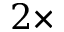Convert formula to latex. <formula><loc_0><loc_0><loc_500><loc_500>2 \times</formula> 